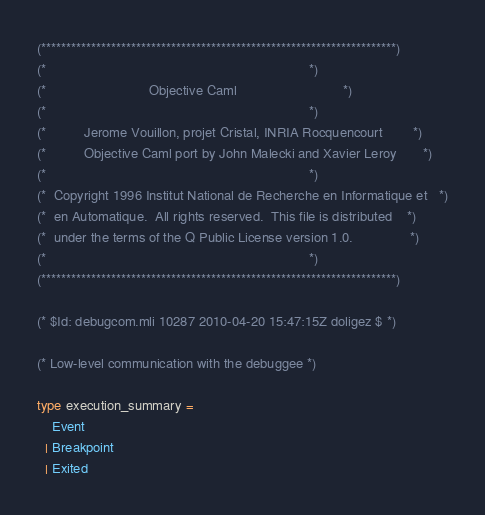<code> <loc_0><loc_0><loc_500><loc_500><_OCaml_>(***********************************************************************)
(*                                                                     *)
(*                           Objective Caml                            *)
(*                                                                     *)
(*          Jerome Vouillon, projet Cristal, INRIA Rocquencourt        *)
(*          Objective Caml port by John Malecki and Xavier Leroy       *)
(*                                                                     *)
(*  Copyright 1996 Institut National de Recherche en Informatique et   *)
(*  en Automatique.  All rights reserved.  This file is distributed    *)
(*  under the terms of the Q Public License version 1.0.               *)
(*                                                                     *)
(***********************************************************************)

(* $Id: debugcom.mli 10287 2010-04-20 15:47:15Z doligez $ *)

(* Low-level communication with the debuggee *)

type execution_summary =
    Event
  | Breakpoint
  | Exited</code> 